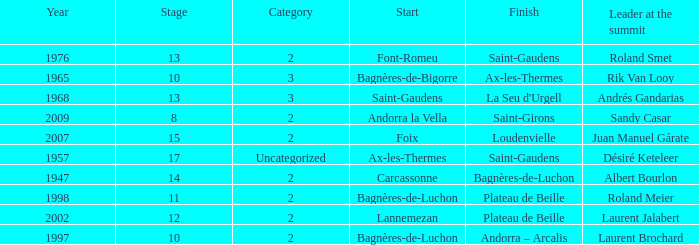Name the start of an event in Catagory 2 of the year 1947. Carcassonne. 